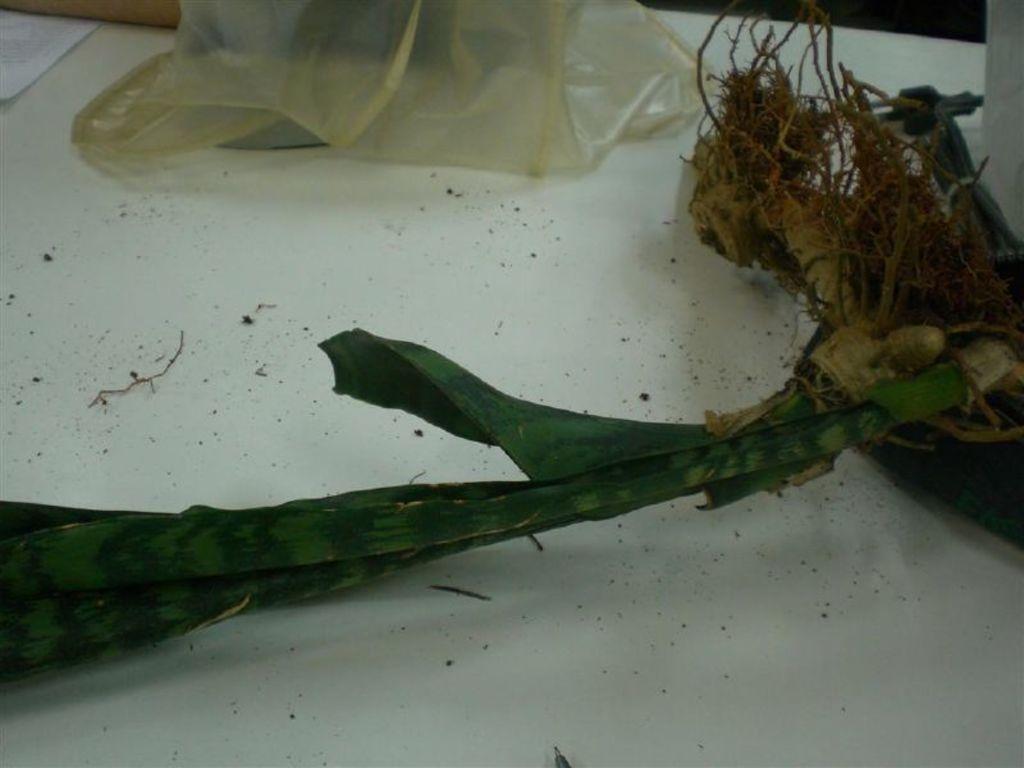Describe this image in one or two sentences. In this picture we can see a plant and a plastic cover on the platform. 